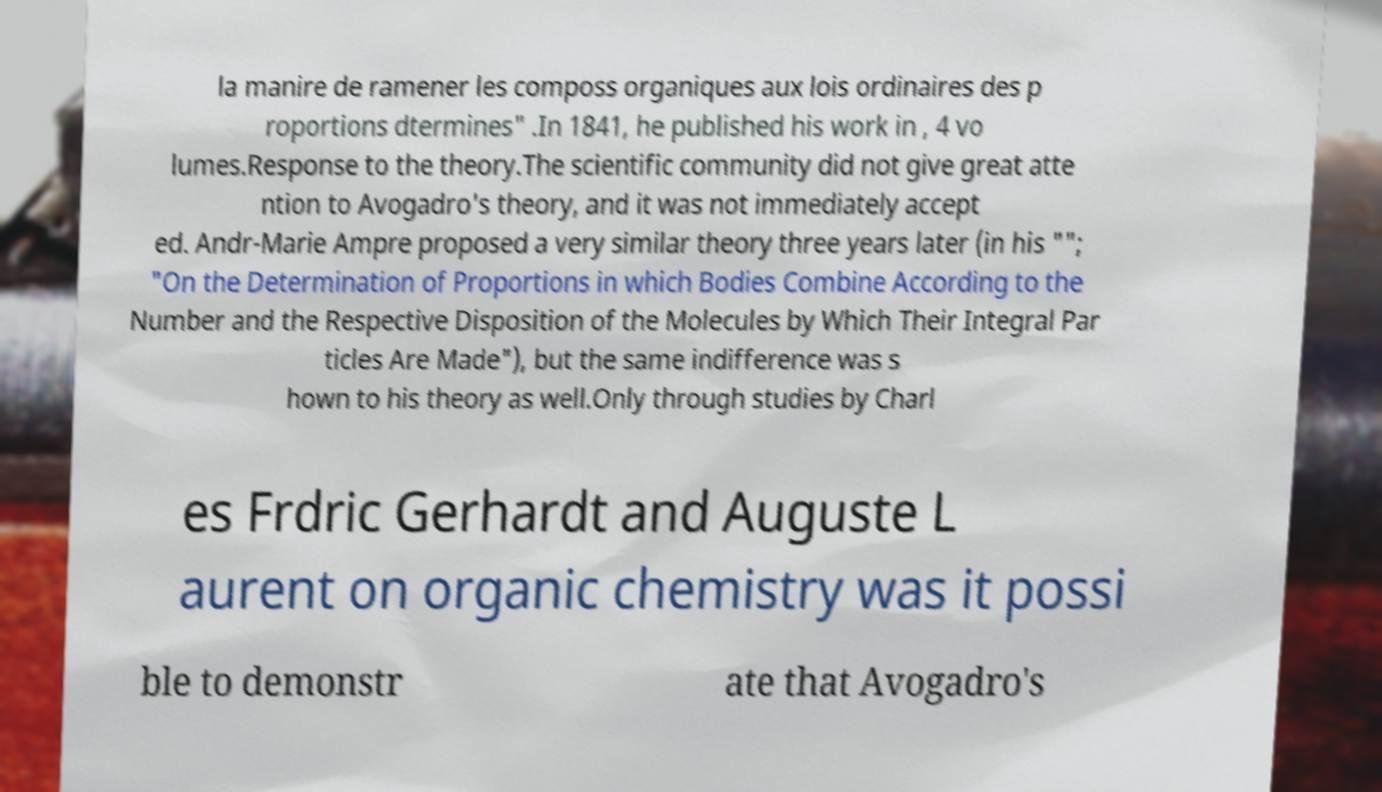Could you extract and type out the text from this image? la manire de ramener les composs organiques aux lois ordinaires des p roportions dtermines" .In 1841, he published his work in , 4 vo lumes.Response to the theory.The scientific community did not give great atte ntion to Avogadro's theory, and it was not immediately accept ed. Andr-Marie Ampre proposed a very similar theory three years later (in his ""; "On the Determination of Proportions in which Bodies Combine According to the Number and the Respective Disposition of the Molecules by Which Their Integral Par ticles Are Made"), but the same indifference was s hown to his theory as well.Only through studies by Charl es Frdric Gerhardt and Auguste L aurent on organic chemistry was it possi ble to demonstr ate that Avogadro's 